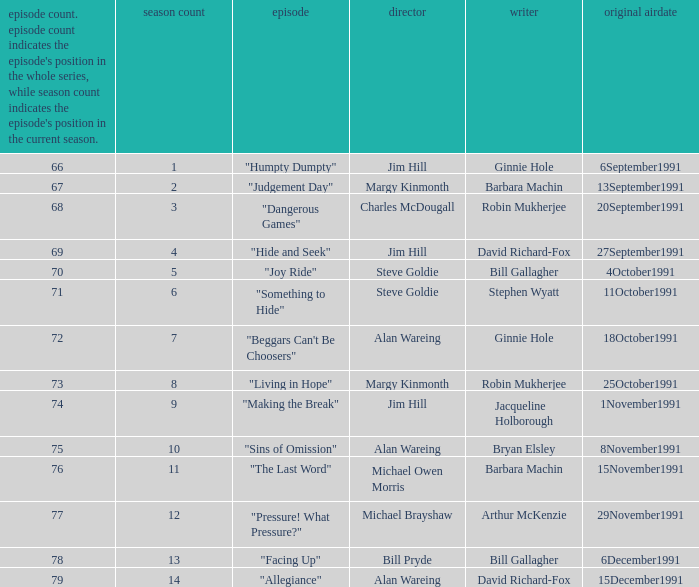Name the least series number for episode number being 78 13.0. 